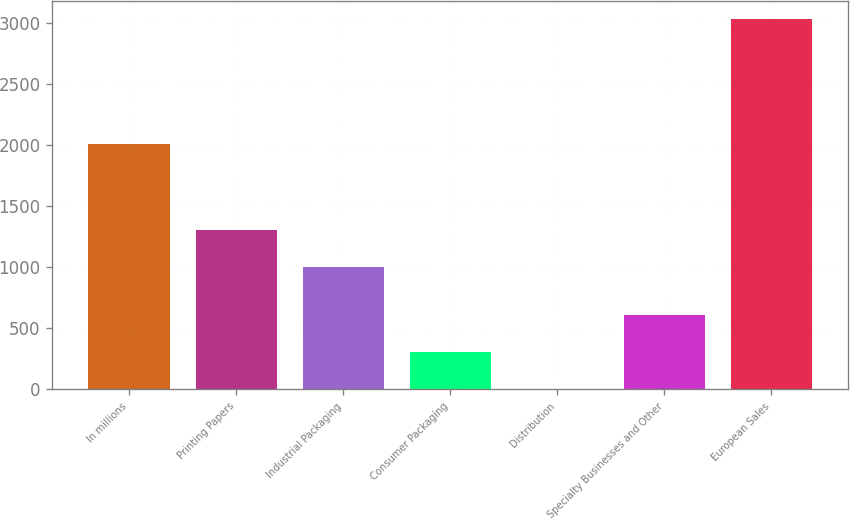<chart> <loc_0><loc_0><loc_500><loc_500><bar_chart><fcel>In millions<fcel>Printing Papers<fcel>Industrial Packaging<fcel>Consumer Packaging<fcel>Distribution<fcel>Specialty Businesses and Other<fcel>European Sales<nl><fcel>2006<fcel>1303.9<fcel>1001<fcel>303.9<fcel>1<fcel>606.8<fcel>3030<nl></chart> 